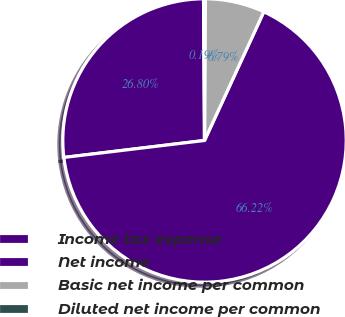Convert chart. <chart><loc_0><loc_0><loc_500><loc_500><pie_chart><fcel>Income tax expense<fcel>Net income<fcel>Basic net income per common<fcel>Diluted net income per common<nl><fcel>26.8%<fcel>66.21%<fcel>6.79%<fcel>0.19%<nl></chart> 